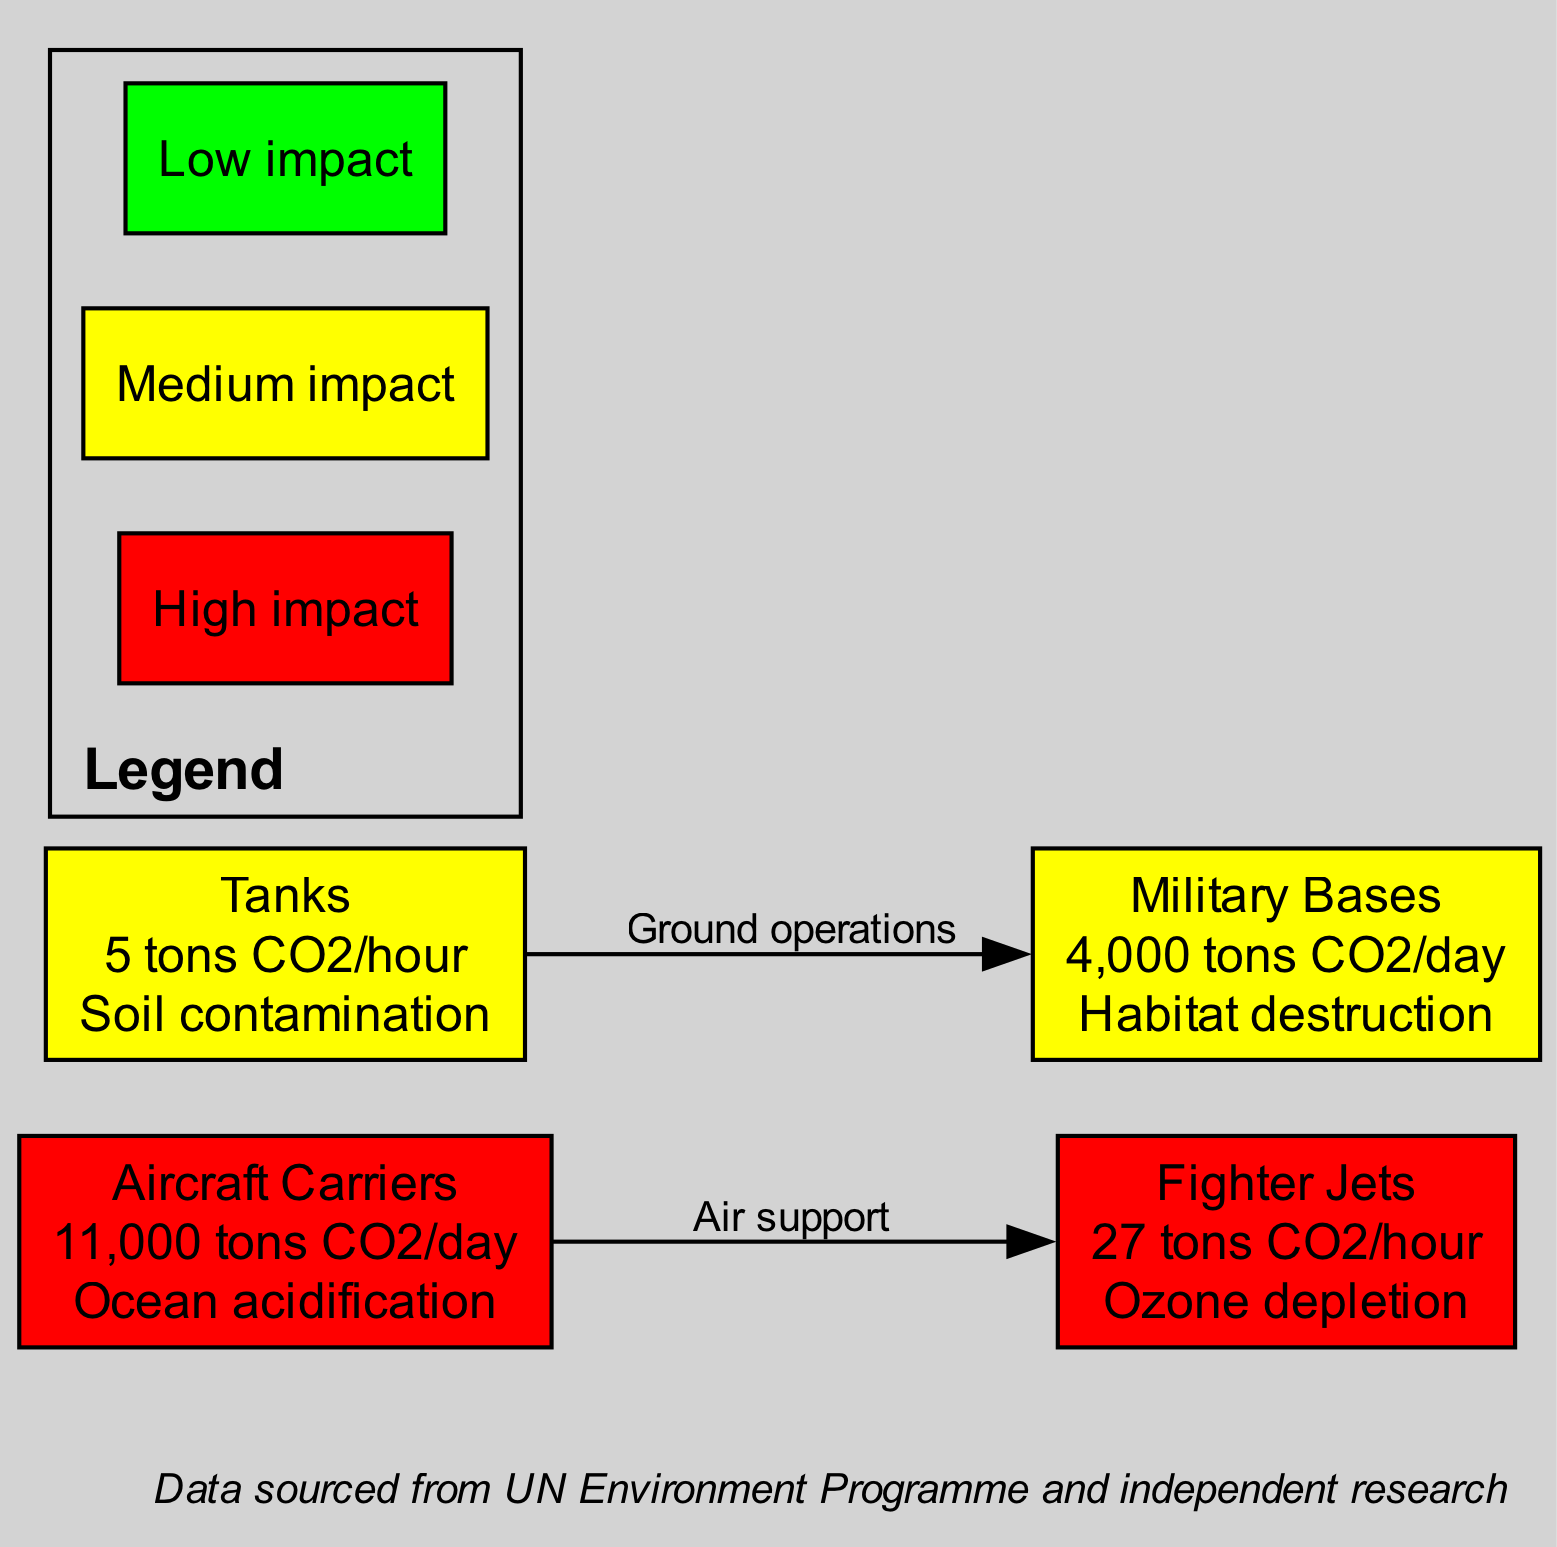What is the carbon footprint of aircraft carriers? The diagram lists the emission associated with aircraft carriers as 11,000 tons CO2/day. This information is found directly in the node labeled "Aircraft Carriers."
Answer: 11,000 tons CO2/day What environmental consequence is associated with military bases? In the diagram, the consequence linked to military bases is habitat destruction, as specified in the corresponding node labeled "Military Bases."
Answer: Habitat destruction Which military operation has the highest CO2 emissions per day? By comparing the emissions listed in the nodes, aircraft carriers emit 11,000 tons CO2/day, which is greater than the 4,000 tons CO2/day associated with military bases. Therefore, it's the operation with the highest emissions.
Answer: Aircraft Carriers How many edges are shown in the diagram? The diagram includes two edges connecting the nodes. Specifically, there are connections for air support from aircraft carriers to fighter jets and for ground operations from tanks to military bases.
Answer: 2 What is the emission level color classification for tanks? The emission for tanks is 5 tons CO2/hour. According to the color coding, this corresponds to a yellow classification since emissions greater than 5 tons CO2/hour are considered medium impact, which is colored yellow.
Answer: Yellow Which military operation is associated with ozone depletion? The diagram indicates that fighter jets are linked to ozone depletion, as noted in the node specifying the fighter jets.
Answer: Fighter Jets What type of operations does the edge labeled "Air support" connect? The edge labeled "Air support" connects the node for aircraft carriers, which highlights their role in supporting fighter jets.
Answer: Aircraft Carriers and Fighter Jets What is the lowest recorded CO2 emission per hour among the military operations? The diagram shows that tanks emit 5 tons CO2/hour, which is the lowest compared to the 27 tons CO2/hour from fighter jets.
Answer: 5 tons CO2/hour What does the red color in the legend signify? The red color in the legend indicates a high impact, reflecting the significant environmental consequences of that particular military operation's carbon footprint.
Answer: High impact 